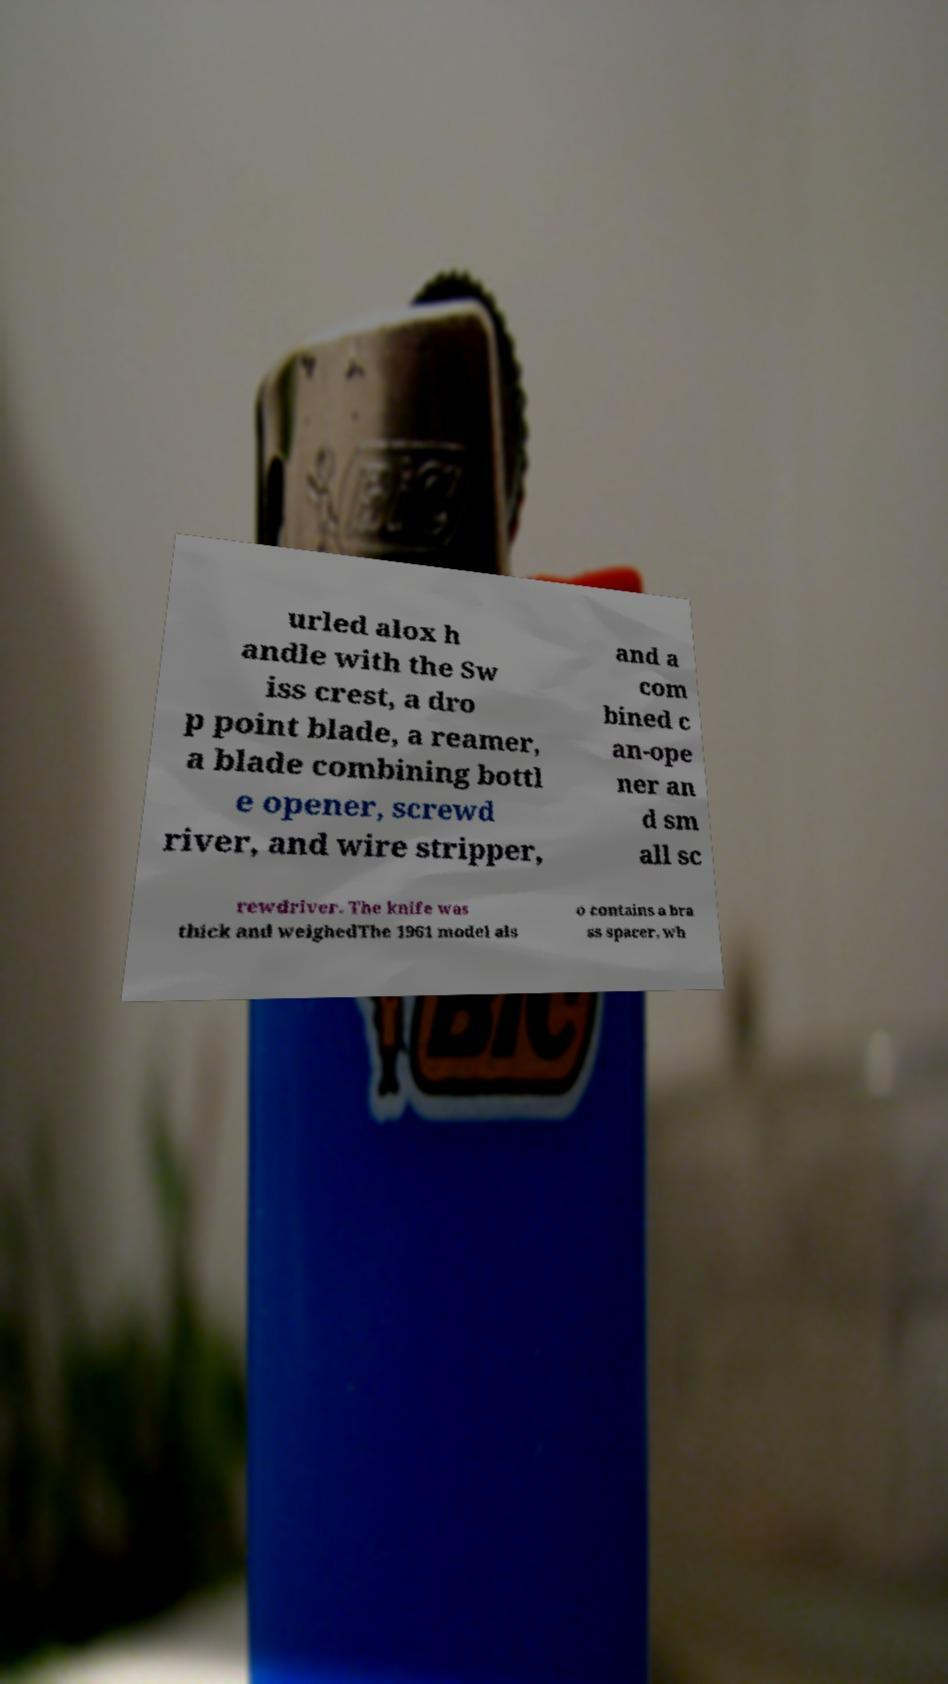What messages or text are displayed in this image? I need them in a readable, typed format. urled alox h andle with the Sw iss crest, a dro p point blade, a reamer, a blade combining bottl e opener, screwd river, and wire stripper, and a com bined c an-ope ner an d sm all sc rewdriver. The knife was thick and weighedThe 1961 model als o contains a bra ss spacer, wh 